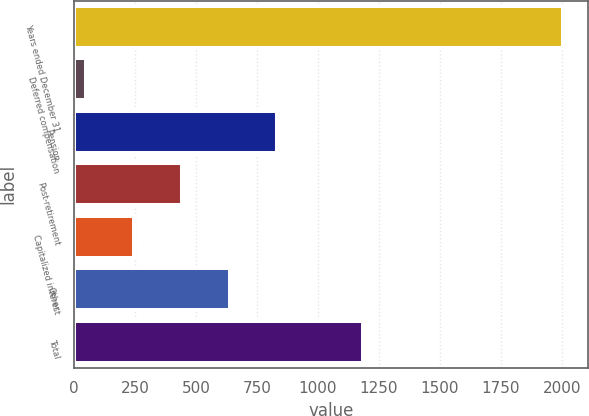Convert chart. <chart><loc_0><loc_0><loc_500><loc_500><bar_chart><fcel>Years ended December 31<fcel>Deferred compensation<fcel>Pension<fcel>Post-retirement<fcel>Capitalized interest<fcel>Other<fcel>Total<nl><fcel>2007<fcel>51<fcel>833.4<fcel>442.2<fcel>246.6<fcel>637.8<fcel>1185<nl></chart> 